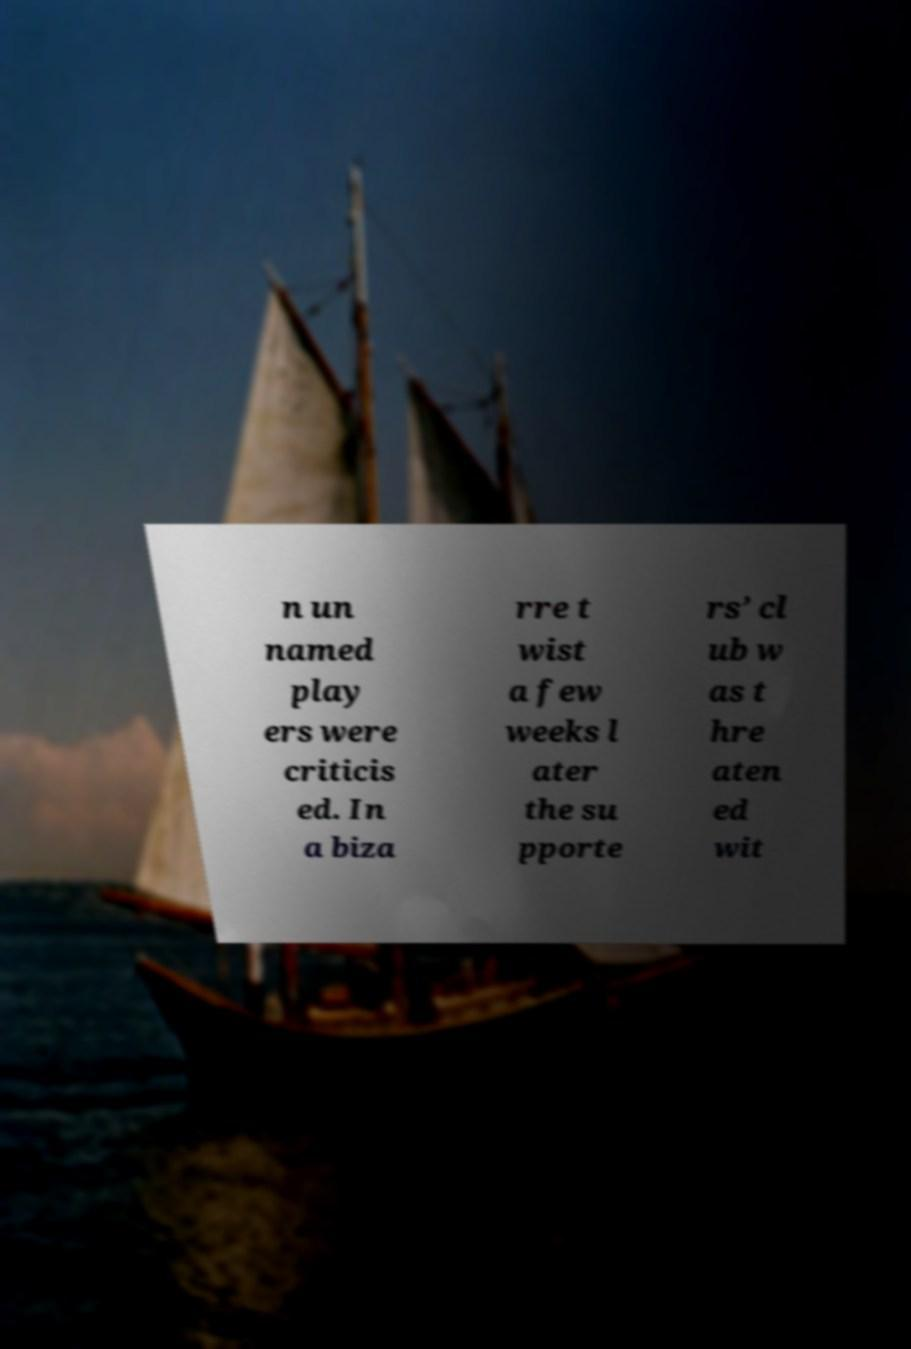Could you extract and type out the text from this image? n un named play ers were criticis ed. In a biza rre t wist a few weeks l ater the su pporte rs’ cl ub w as t hre aten ed wit 